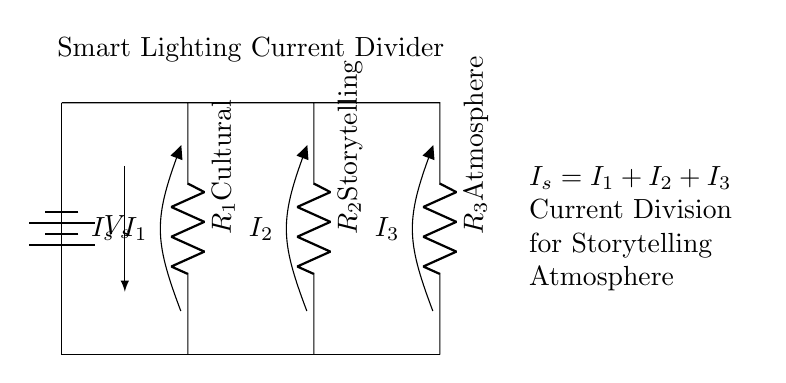What is the total current input to the circuit? The total current input, denoted as I_s, is the sum of the currents through each resistor (I_1, I_2, I_3). According to Kirchhoff’s Current Law, the total current entering a junction equals the sum of currents flowing out.
Answer: I_s What is the role of resistor R_1 in this circuit? Resistor R_1 is labeled "Cultural" and represents one of the paths that the total current I_s can flow through. It influences how much of the total current is allocated to creating a cultural atmosphere during storytelling.
Answer: Cultural How many resistors are present in the circuit? There are three resistors in the circuit, labeled R_1, R_2, and R_3. Each resistor serves a different purpose related to the storytelling session's ambiance.
Answer: 3 What is the name given to the circuit configuration? The configuration of this circuit is referred to as a "Current Divider," which distributes the total input current among the parallel resistors. Each output current through the resistors varies based on their resistance values.
Answer: Current Divider Which resistor is associated with "Storytelling"? The resistor associated with "Storytelling" is R_2, which is designated specifically for the purpose of creating a storytelling atmosphere through adjusted lighting. It demonstrates the adaptability of the lighting based on the session's theme.
Answer: R_2 What is the formula representing current division in this circuit? The formula representing the current division states that the total input current (I_s) is equal to the sum of the currents through each resistor (I_1 + I_2 + I_3). This shows how input current is distributed in the circuit.
Answer: I_s = I_1 + I_2 + I_3 